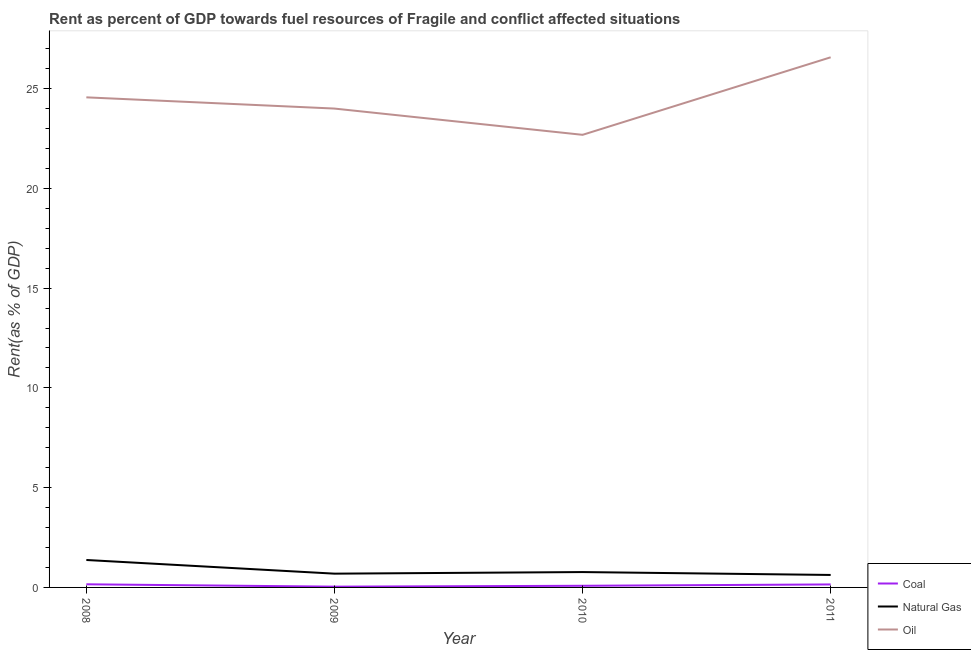How many different coloured lines are there?
Provide a succinct answer. 3. Does the line corresponding to rent towards coal intersect with the line corresponding to rent towards natural gas?
Offer a terse response. No. What is the rent towards oil in 2010?
Provide a short and direct response. 22.68. Across all years, what is the maximum rent towards coal?
Make the answer very short. 0.16. Across all years, what is the minimum rent towards natural gas?
Your response must be concise. 0.62. In which year was the rent towards natural gas maximum?
Offer a terse response. 2008. In which year was the rent towards oil minimum?
Provide a succinct answer. 2010. What is the total rent towards natural gas in the graph?
Your response must be concise. 3.46. What is the difference between the rent towards oil in 2008 and that in 2009?
Provide a short and direct response. 0.56. What is the difference between the rent towards oil in 2008 and the rent towards natural gas in 2009?
Provide a short and direct response. 23.87. What is the average rent towards coal per year?
Offer a terse response. 0.11. In the year 2011, what is the difference between the rent towards coal and rent towards oil?
Keep it short and to the point. -26.42. What is the ratio of the rent towards coal in 2008 to that in 2011?
Provide a short and direct response. 1.05. Is the difference between the rent towards coal in 2008 and 2009 greater than the difference between the rent towards natural gas in 2008 and 2009?
Provide a succinct answer. No. What is the difference between the highest and the second highest rent towards coal?
Keep it short and to the point. 0.01. What is the difference between the highest and the lowest rent towards natural gas?
Your answer should be very brief. 0.75. In how many years, is the rent towards natural gas greater than the average rent towards natural gas taken over all years?
Give a very brief answer. 1. Is the sum of the rent towards natural gas in 2008 and 2011 greater than the maximum rent towards oil across all years?
Your response must be concise. No. Does the rent towards coal monotonically increase over the years?
Make the answer very short. No. Is the rent towards natural gas strictly less than the rent towards oil over the years?
Your answer should be compact. Yes. How many lines are there?
Your response must be concise. 3. How many years are there in the graph?
Keep it short and to the point. 4. What is the difference between two consecutive major ticks on the Y-axis?
Your answer should be compact. 5. Are the values on the major ticks of Y-axis written in scientific E-notation?
Your answer should be very brief. No. Does the graph contain any zero values?
Your answer should be very brief. No. Where does the legend appear in the graph?
Your answer should be compact. Bottom right. How are the legend labels stacked?
Your answer should be very brief. Vertical. What is the title of the graph?
Your response must be concise. Rent as percent of GDP towards fuel resources of Fragile and conflict affected situations. What is the label or title of the X-axis?
Give a very brief answer. Year. What is the label or title of the Y-axis?
Keep it short and to the point. Rent(as % of GDP). What is the Rent(as % of GDP) of Coal in 2008?
Ensure brevity in your answer.  0.16. What is the Rent(as % of GDP) of Natural Gas in 2008?
Make the answer very short. 1.38. What is the Rent(as % of GDP) of Oil in 2008?
Ensure brevity in your answer.  24.56. What is the Rent(as % of GDP) of Coal in 2009?
Give a very brief answer. 0.04. What is the Rent(as % of GDP) of Natural Gas in 2009?
Your answer should be compact. 0.69. What is the Rent(as % of GDP) of Oil in 2009?
Your response must be concise. 24. What is the Rent(as % of GDP) in Coal in 2010?
Give a very brief answer. 0.08. What is the Rent(as % of GDP) in Natural Gas in 2010?
Your answer should be very brief. 0.77. What is the Rent(as % of GDP) in Oil in 2010?
Your answer should be very brief. 22.68. What is the Rent(as % of GDP) of Coal in 2011?
Provide a succinct answer. 0.15. What is the Rent(as % of GDP) of Natural Gas in 2011?
Your response must be concise. 0.62. What is the Rent(as % of GDP) in Oil in 2011?
Provide a succinct answer. 26.57. Across all years, what is the maximum Rent(as % of GDP) in Coal?
Offer a terse response. 0.16. Across all years, what is the maximum Rent(as % of GDP) of Natural Gas?
Ensure brevity in your answer.  1.38. Across all years, what is the maximum Rent(as % of GDP) in Oil?
Offer a very short reply. 26.57. Across all years, what is the minimum Rent(as % of GDP) of Coal?
Provide a short and direct response. 0.04. Across all years, what is the minimum Rent(as % of GDP) of Natural Gas?
Provide a succinct answer. 0.62. Across all years, what is the minimum Rent(as % of GDP) in Oil?
Ensure brevity in your answer.  22.68. What is the total Rent(as % of GDP) in Coal in the graph?
Your response must be concise. 0.43. What is the total Rent(as % of GDP) in Natural Gas in the graph?
Provide a succinct answer. 3.46. What is the total Rent(as % of GDP) of Oil in the graph?
Provide a short and direct response. 97.8. What is the difference between the Rent(as % of GDP) of Coal in 2008 and that in 2009?
Your answer should be very brief. 0.12. What is the difference between the Rent(as % of GDP) in Natural Gas in 2008 and that in 2009?
Keep it short and to the point. 0.69. What is the difference between the Rent(as % of GDP) in Oil in 2008 and that in 2009?
Provide a succinct answer. 0.56. What is the difference between the Rent(as % of GDP) of Coal in 2008 and that in 2010?
Offer a very short reply. 0.07. What is the difference between the Rent(as % of GDP) of Natural Gas in 2008 and that in 2010?
Provide a short and direct response. 0.61. What is the difference between the Rent(as % of GDP) of Oil in 2008 and that in 2010?
Provide a succinct answer. 1.88. What is the difference between the Rent(as % of GDP) in Coal in 2008 and that in 2011?
Your answer should be compact. 0.01. What is the difference between the Rent(as % of GDP) in Natural Gas in 2008 and that in 2011?
Provide a short and direct response. 0.75. What is the difference between the Rent(as % of GDP) of Oil in 2008 and that in 2011?
Keep it short and to the point. -2.01. What is the difference between the Rent(as % of GDP) of Coal in 2009 and that in 2010?
Make the answer very short. -0.04. What is the difference between the Rent(as % of GDP) in Natural Gas in 2009 and that in 2010?
Make the answer very short. -0.08. What is the difference between the Rent(as % of GDP) of Oil in 2009 and that in 2010?
Offer a very short reply. 1.32. What is the difference between the Rent(as % of GDP) in Coal in 2009 and that in 2011?
Your response must be concise. -0.11. What is the difference between the Rent(as % of GDP) of Natural Gas in 2009 and that in 2011?
Your response must be concise. 0.07. What is the difference between the Rent(as % of GDP) of Oil in 2009 and that in 2011?
Offer a terse response. -2.57. What is the difference between the Rent(as % of GDP) in Coal in 2010 and that in 2011?
Give a very brief answer. -0.07. What is the difference between the Rent(as % of GDP) of Natural Gas in 2010 and that in 2011?
Offer a terse response. 0.15. What is the difference between the Rent(as % of GDP) in Oil in 2010 and that in 2011?
Make the answer very short. -3.89. What is the difference between the Rent(as % of GDP) of Coal in 2008 and the Rent(as % of GDP) of Natural Gas in 2009?
Ensure brevity in your answer.  -0.53. What is the difference between the Rent(as % of GDP) of Coal in 2008 and the Rent(as % of GDP) of Oil in 2009?
Offer a terse response. -23.84. What is the difference between the Rent(as % of GDP) in Natural Gas in 2008 and the Rent(as % of GDP) in Oil in 2009?
Your answer should be compact. -22.62. What is the difference between the Rent(as % of GDP) of Coal in 2008 and the Rent(as % of GDP) of Natural Gas in 2010?
Provide a succinct answer. -0.61. What is the difference between the Rent(as % of GDP) in Coal in 2008 and the Rent(as % of GDP) in Oil in 2010?
Provide a succinct answer. -22.52. What is the difference between the Rent(as % of GDP) in Natural Gas in 2008 and the Rent(as % of GDP) in Oil in 2010?
Provide a succinct answer. -21.31. What is the difference between the Rent(as % of GDP) in Coal in 2008 and the Rent(as % of GDP) in Natural Gas in 2011?
Give a very brief answer. -0.47. What is the difference between the Rent(as % of GDP) in Coal in 2008 and the Rent(as % of GDP) in Oil in 2011?
Provide a short and direct response. -26.41. What is the difference between the Rent(as % of GDP) in Natural Gas in 2008 and the Rent(as % of GDP) in Oil in 2011?
Offer a very short reply. -25.19. What is the difference between the Rent(as % of GDP) of Coal in 2009 and the Rent(as % of GDP) of Natural Gas in 2010?
Give a very brief answer. -0.73. What is the difference between the Rent(as % of GDP) of Coal in 2009 and the Rent(as % of GDP) of Oil in 2010?
Your answer should be compact. -22.64. What is the difference between the Rent(as % of GDP) in Natural Gas in 2009 and the Rent(as % of GDP) in Oil in 2010?
Ensure brevity in your answer.  -21.99. What is the difference between the Rent(as % of GDP) in Coal in 2009 and the Rent(as % of GDP) in Natural Gas in 2011?
Make the answer very short. -0.59. What is the difference between the Rent(as % of GDP) of Coal in 2009 and the Rent(as % of GDP) of Oil in 2011?
Keep it short and to the point. -26.53. What is the difference between the Rent(as % of GDP) of Natural Gas in 2009 and the Rent(as % of GDP) of Oil in 2011?
Your answer should be very brief. -25.88. What is the difference between the Rent(as % of GDP) in Coal in 2010 and the Rent(as % of GDP) in Natural Gas in 2011?
Give a very brief answer. -0.54. What is the difference between the Rent(as % of GDP) of Coal in 2010 and the Rent(as % of GDP) of Oil in 2011?
Ensure brevity in your answer.  -26.48. What is the difference between the Rent(as % of GDP) of Natural Gas in 2010 and the Rent(as % of GDP) of Oil in 2011?
Your answer should be compact. -25.8. What is the average Rent(as % of GDP) of Coal per year?
Ensure brevity in your answer.  0.11. What is the average Rent(as % of GDP) in Natural Gas per year?
Keep it short and to the point. 0.87. What is the average Rent(as % of GDP) in Oil per year?
Ensure brevity in your answer.  24.45. In the year 2008, what is the difference between the Rent(as % of GDP) of Coal and Rent(as % of GDP) of Natural Gas?
Your answer should be compact. -1.22. In the year 2008, what is the difference between the Rent(as % of GDP) in Coal and Rent(as % of GDP) in Oil?
Offer a terse response. -24.4. In the year 2008, what is the difference between the Rent(as % of GDP) of Natural Gas and Rent(as % of GDP) of Oil?
Offer a terse response. -23.18. In the year 2009, what is the difference between the Rent(as % of GDP) of Coal and Rent(as % of GDP) of Natural Gas?
Offer a very short reply. -0.65. In the year 2009, what is the difference between the Rent(as % of GDP) in Coal and Rent(as % of GDP) in Oil?
Provide a short and direct response. -23.96. In the year 2009, what is the difference between the Rent(as % of GDP) of Natural Gas and Rent(as % of GDP) of Oil?
Offer a terse response. -23.31. In the year 2010, what is the difference between the Rent(as % of GDP) of Coal and Rent(as % of GDP) of Natural Gas?
Keep it short and to the point. -0.69. In the year 2010, what is the difference between the Rent(as % of GDP) of Coal and Rent(as % of GDP) of Oil?
Offer a very short reply. -22.6. In the year 2010, what is the difference between the Rent(as % of GDP) of Natural Gas and Rent(as % of GDP) of Oil?
Your answer should be very brief. -21.91. In the year 2011, what is the difference between the Rent(as % of GDP) in Coal and Rent(as % of GDP) in Natural Gas?
Provide a succinct answer. -0.48. In the year 2011, what is the difference between the Rent(as % of GDP) in Coal and Rent(as % of GDP) in Oil?
Ensure brevity in your answer.  -26.42. In the year 2011, what is the difference between the Rent(as % of GDP) of Natural Gas and Rent(as % of GDP) of Oil?
Ensure brevity in your answer.  -25.94. What is the ratio of the Rent(as % of GDP) in Coal in 2008 to that in 2009?
Make the answer very short. 4.06. What is the ratio of the Rent(as % of GDP) in Natural Gas in 2008 to that in 2009?
Your response must be concise. 1.99. What is the ratio of the Rent(as % of GDP) of Oil in 2008 to that in 2009?
Give a very brief answer. 1.02. What is the ratio of the Rent(as % of GDP) in Coal in 2008 to that in 2010?
Provide a short and direct response. 1.91. What is the ratio of the Rent(as % of GDP) in Natural Gas in 2008 to that in 2010?
Your answer should be compact. 1.79. What is the ratio of the Rent(as % of GDP) of Oil in 2008 to that in 2010?
Your answer should be very brief. 1.08. What is the ratio of the Rent(as % of GDP) in Coal in 2008 to that in 2011?
Offer a very short reply. 1.05. What is the ratio of the Rent(as % of GDP) in Natural Gas in 2008 to that in 2011?
Your answer should be very brief. 2.2. What is the ratio of the Rent(as % of GDP) in Oil in 2008 to that in 2011?
Offer a terse response. 0.92. What is the ratio of the Rent(as % of GDP) of Coal in 2009 to that in 2010?
Give a very brief answer. 0.47. What is the ratio of the Rent(as % of GDP) in Natural Gas in 2009 to that in 2010?
Keep it short and to the point. 0.9. What is the ratio of the Rent(as % of GDP) in Oil in 2009 to that in 2010?
Your answer should be compact. 1.06. What is the ratio of the Rent(as % of GDP) in Coal in 2009 to that in 2011?
Provide a succinct answer. 0.26. What is the ratio of the Rent(as % of GDP) of Natural Gas in 2009 to that in 2011?
Keep it short and to the point. 1.1. What is the ratio of the Rent(as % of GDP) of Oil in 2009 to that in 2011?
Your response must be concise. 0.9. What is the ratio of the Rent(as % of GDP) in Coal in 2010 to that in 2011?
Your answer should be compact. 0.55. What is the ratio of the Rent(as % of GDP) in Natural Gas in 2010 to that in 2011?
Offer a terse response. 1.23. What is the ratio of the Rent(as % of GDP) in Oil in 2010 to that in 2011?
Your answer should be very brief. 0.85. What is the difference between the highest and the second highest Rent(as % of GDP) of Coal?
Make the answer very short. 0.01. What is the difference between the highest and the second highest Rent(as % of GDP) in Natural Gas?
Your answer should be compact. 0.61. What is the difference between the highest and the second highest Rent(as % of GDP) in Oil?
Ensure brevity in your answer.  2.01. What is the difference between the highest and the lowest Rent(as % of GDP) in Coal?
Give a very brief answer. 0.12. What is the difference between the highest and the lowest Rent(as % of GDP) in Natural Gas?
Your response must be concise. 0.75. What is the difference between the highest and the lowest Rent(as % of GDP) in Oil?
Make the answer very short. 3.89. 